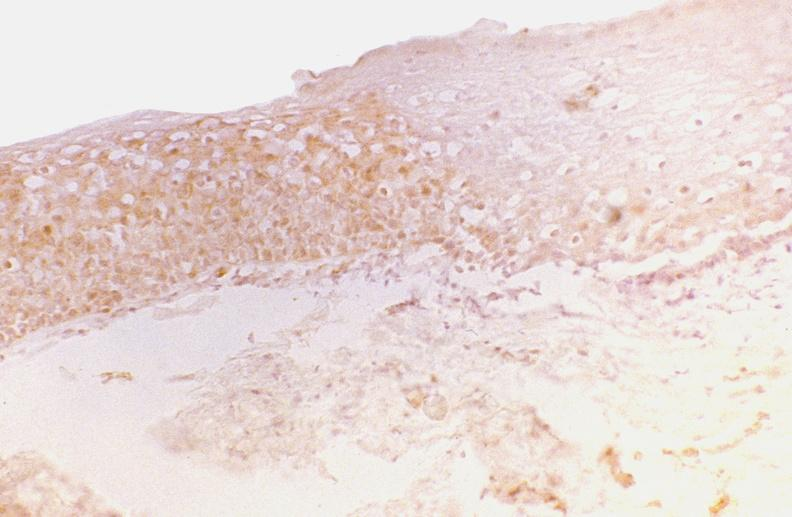what is present?
Answer the question using a single word or phrase. Gastrointestinal 